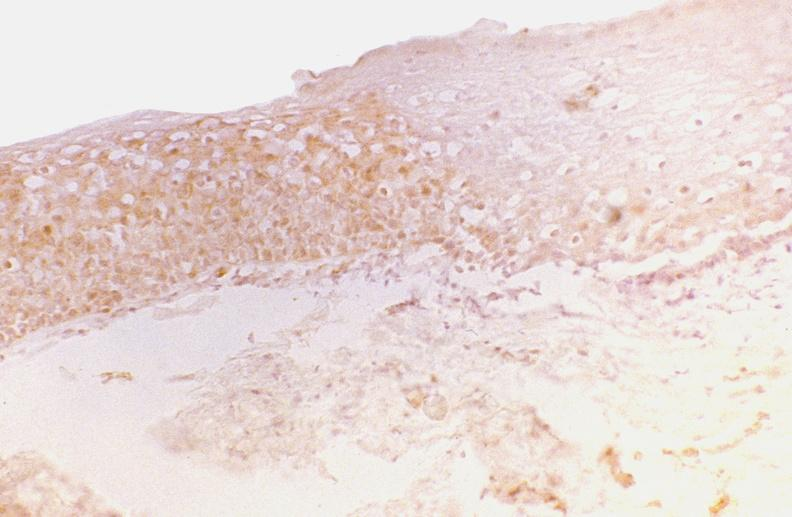what is present?
Answer the question using a single word or phrase. Gastrointestinal 